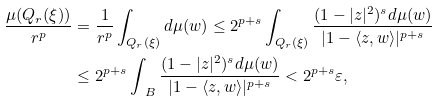<formula> <loc_0><loc_0><loc_500><loc_500>\frac { \mu ( Q _ { r } ( \xi ) ) } { r ^ { p } } & = \frac { 1 } { r ^ { p } } \int _ { Q _ { r } ( \xi ) } d \mu ( w ) \leq 2 ^ { p + s } \int _ { Q _ { r } ( \xi ) } \frac { ( 1 - | z | ^ { 2 } ) ^ { s } d \mu ( w ) } { | 1 - \langle z , w \rangle | ^ { p + s } } \\ & \leq 2 ^ { p + s } \int _ { \ B } \frac { ( 1 - | z | ^ { 2 } ) ^ { s } d \mu ( w ) } { | 1 - \langle z , w \rangle | ^ { p + s } } < 2 ^ { p + s } \varepsilon ,</formula> 